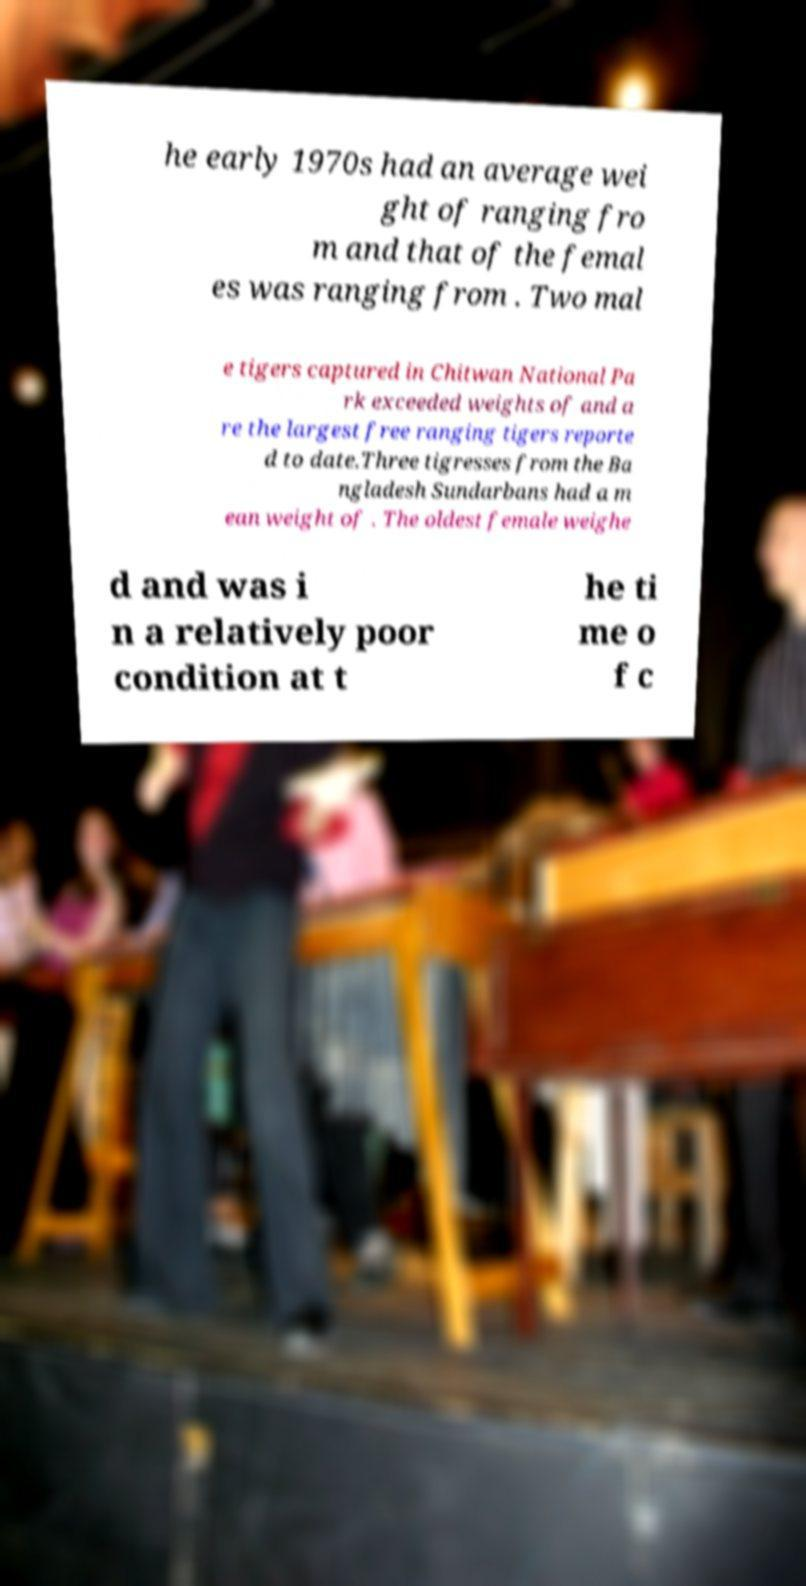Please read and relay the text visible in this image. What does it say? he early 1970s had an average wei ght of ranging fro m and that of the femal es was ranging from . Two mal e tigers captured in Chitwan National Pa rk exceeded weights of and a re the largest free ranging tigers reporte d to date.Three tigresses from the Ba ngladesh Sundarbans had a m ean weight of . The oldest female weighe d and was i n a relatively poor condition at t he ti me o f c 